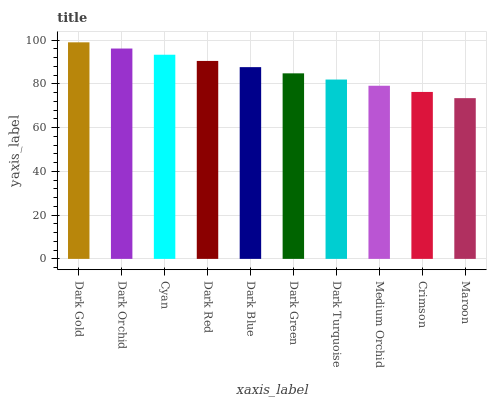Is Maroon the minimum?
Answer yes or no. Yes. Is Dark Gold the maximum?
Answer yes or no. Yes. Is Dark Orchid the minimum?
Answer yes or no. No. Is Dark Orchid the maximum?
Answer yes or no. No. Is Dark Gold greater than Dark Orchid?
Answer yes or no. Yes. Is Dark Orchid less than Dark Gold?
Answer yes or no. Yes. Is Dark Orchid greater than Dark Gold?
Answer yes or no. No. Is Dark Gold less than Dark Orchid?
Answer yes or no. No. Is Dark Blue the high median?
Answer yes or no. Yes. Is Dark Green the low median?
Answer yes or no. Yes. Is Dark Red the high median?
Answer yes or no. No. Is Medium Orchid the low median?
Answer yes or no. No. 